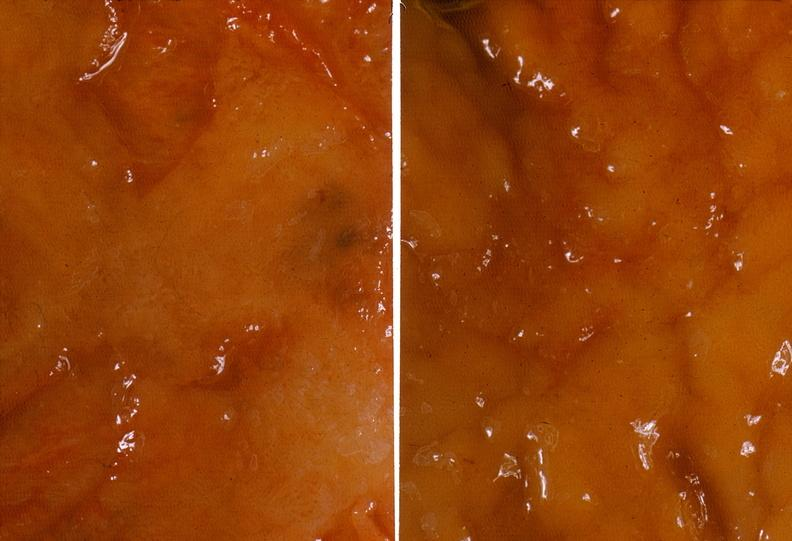what is present?
Answer the question using a single word or phrase. Gastrointestinal 